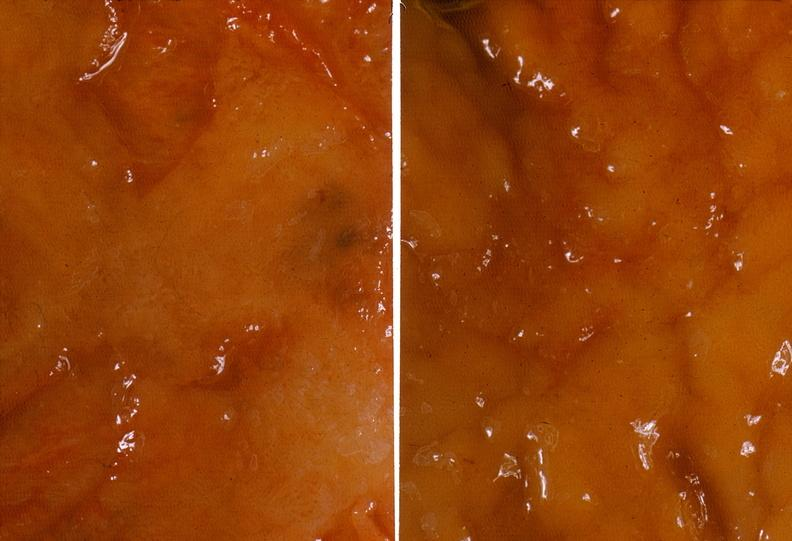what is present?
Answer the question using a single word or phrase. Gastrointestinal 